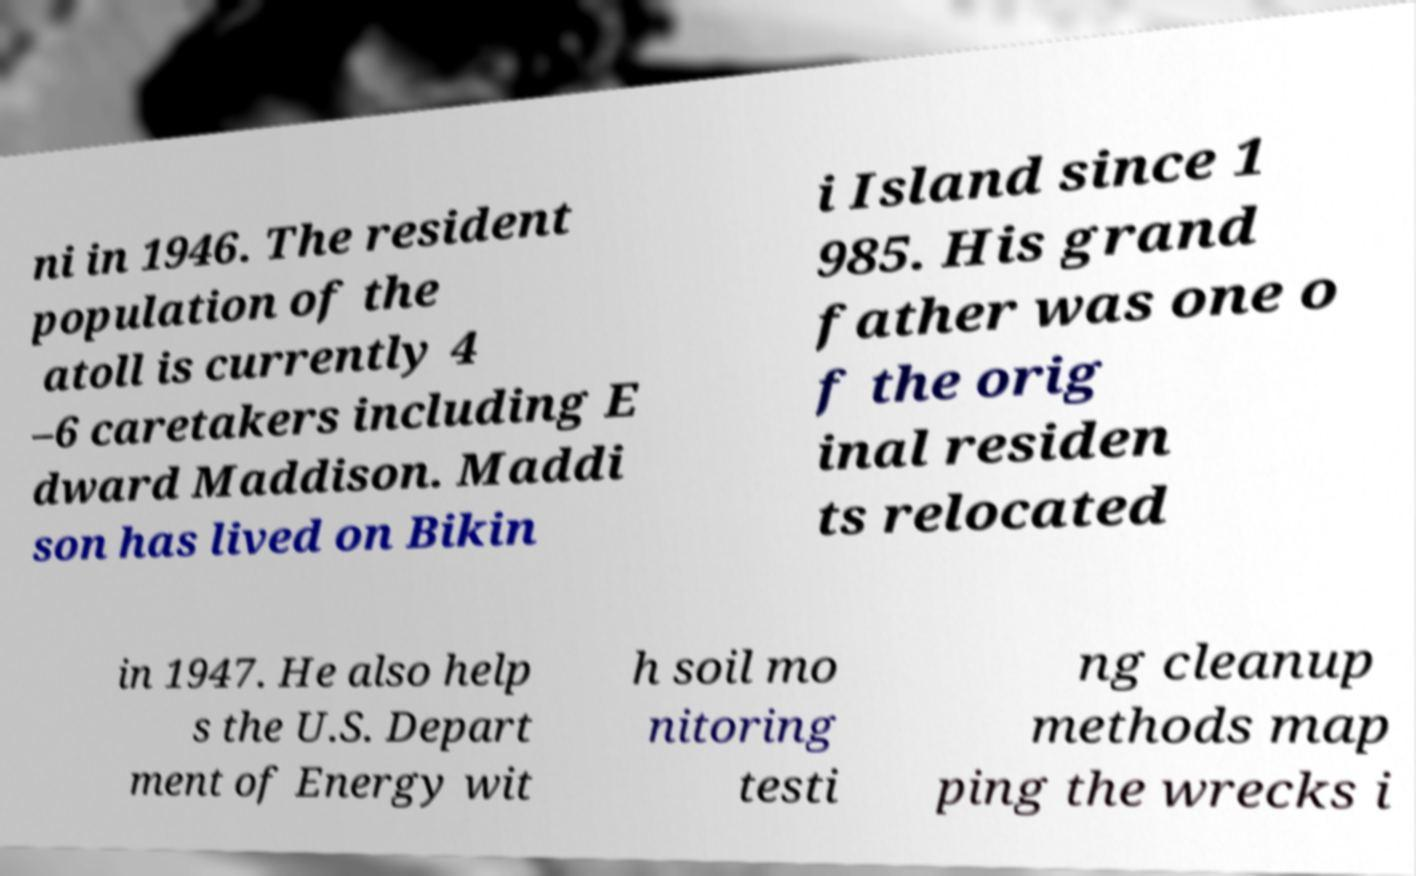Please identify and transcribe the text found in this image. ni in 1946. The resident population of the atoll is currently 4 –6 caretakers including E dward Maddison. Maddi son has lived on Bikin i Island since 1 985. His grand father was one o f the orig inal residen ts relocated in 1947. He also help s the U.S. Depart ment of Energy wit h soil mo nitoring testi ng cleanup methods map ping the wrecks i 